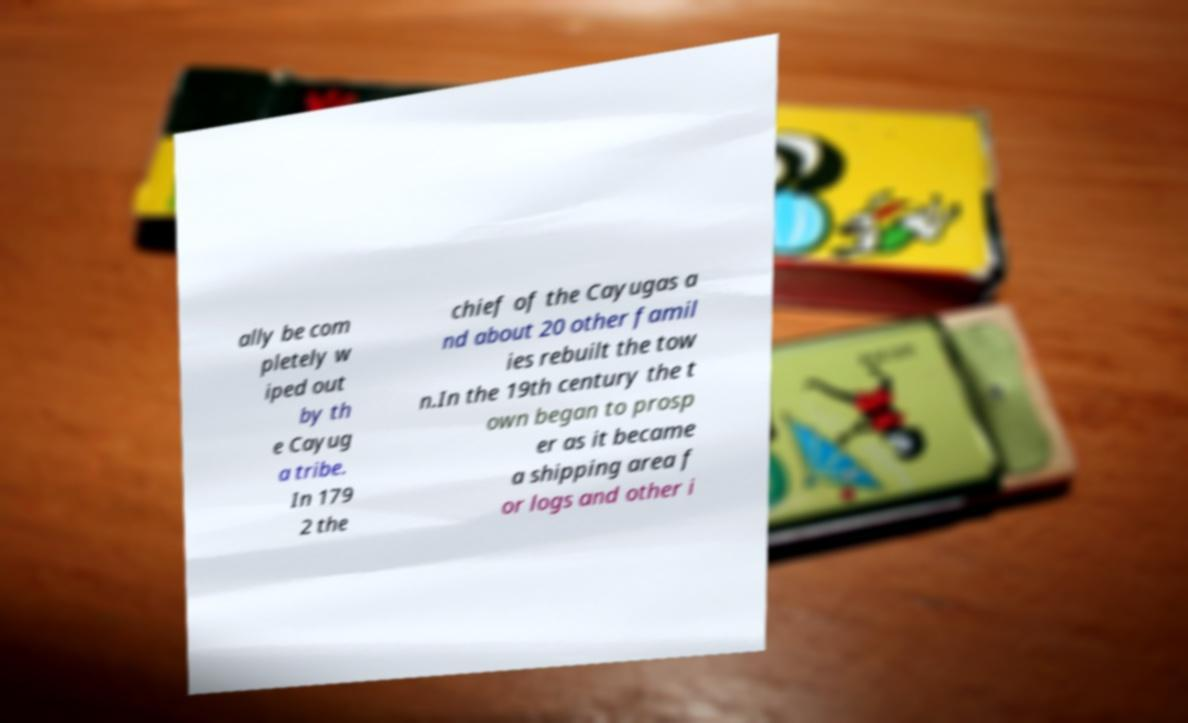Please identify and transcribe the text found in this image. ally be com pletely w iped out by th e Cayug a tribe. In 179 2 the chief of the Cayugas a nd about 20 other famil ies rebuilt the tow n.In the 19th century the t own began to prosp er as it became a shipping area f or logs and other i 